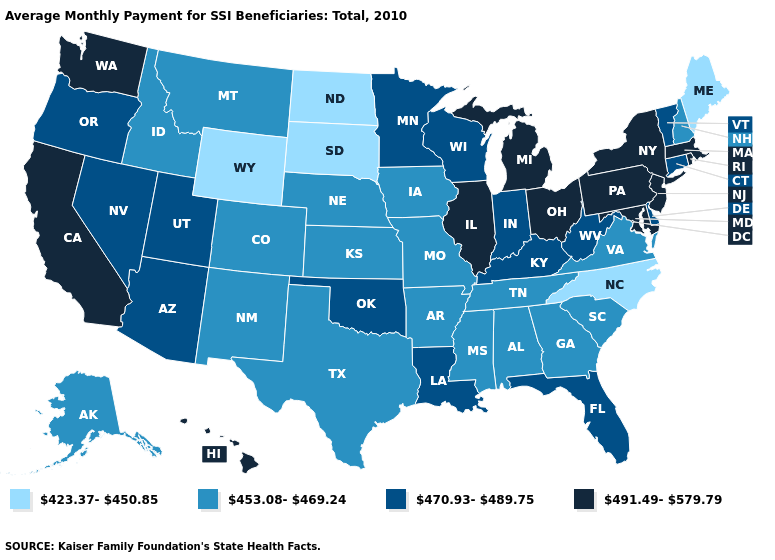Name the states that have a value in the range 423.37-450.85?
Quick response, please. Maine, North Carolina, North Dakota, South Dakota, Wyoming. What is the highest value in states that border Maine?
Give a very brief answer. 453.08-469.24. What is the highest value in states that border California?
Concise answer only. 470.93-489.75. What is the value of Texas?
Be succinct. 453.08-469.24. What is the value of Kentucky?
Give a very brief answer. 470.93-489.75. What is the value of Pennsylvania?
Be succinct. 491.49-579.79. What is the value of Massachusetts?
Write a very short answer. 491.49-579.79. What is the lowest value in the West?
Write a very short answer. 423.37-450.85. What is the value of Delaware?
Concise answer only. 470.93-489.75. What is the value of Oregon?
Be succinct. 470.93-489.75. Name the states that have a value in the range 470.93-489.75?
Keep it brief. Arizona, Connecticut, Delaware, Florida, Indiana, Kentucky, Louisiana, Minnesota, Nevada, Oklahoma, Oregon, Utah, Vermont, West Virginia, Wisconsin. Does the first symbol in the legend represent the smallest category?
Write a very short answer. Yes. What is the lowest value in states that border South Carolina?
Keep it brief. 423.37-450.85. What is the highest value in states that border Maine?
Keep it brief. 453.08-469.24. 